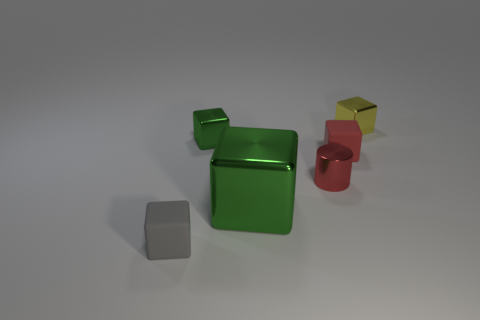What color is the tiny cylinder that is the same material as the large object? The small cylinder that appears to be made of the same material as the larger green object is actually red in color. 